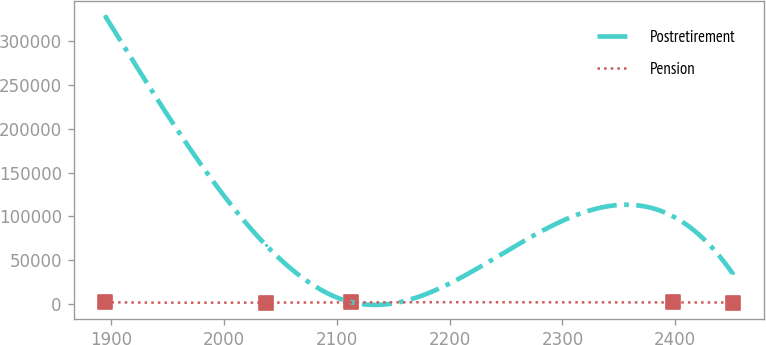Convert chart to OTSL. <chart><loc_0><loc_0><loc_500><loc_500><line_chart><ecel><fcel>Postretirement<fcel>Pension<nl><fcel>1894.14<fcel>329448<fcel>1840.62<nl><fcel>2036.67<fcel>67567<fcel>1476.61<nl><fcel>2112.34<fcel>2096.73<fcel>1804.29<nl><fcel>2397.71<fcel>100302<fcel>1623.04<nl><fcel>2450.93<fcel>34831.9<fcel>1586.71<nl></chart> 